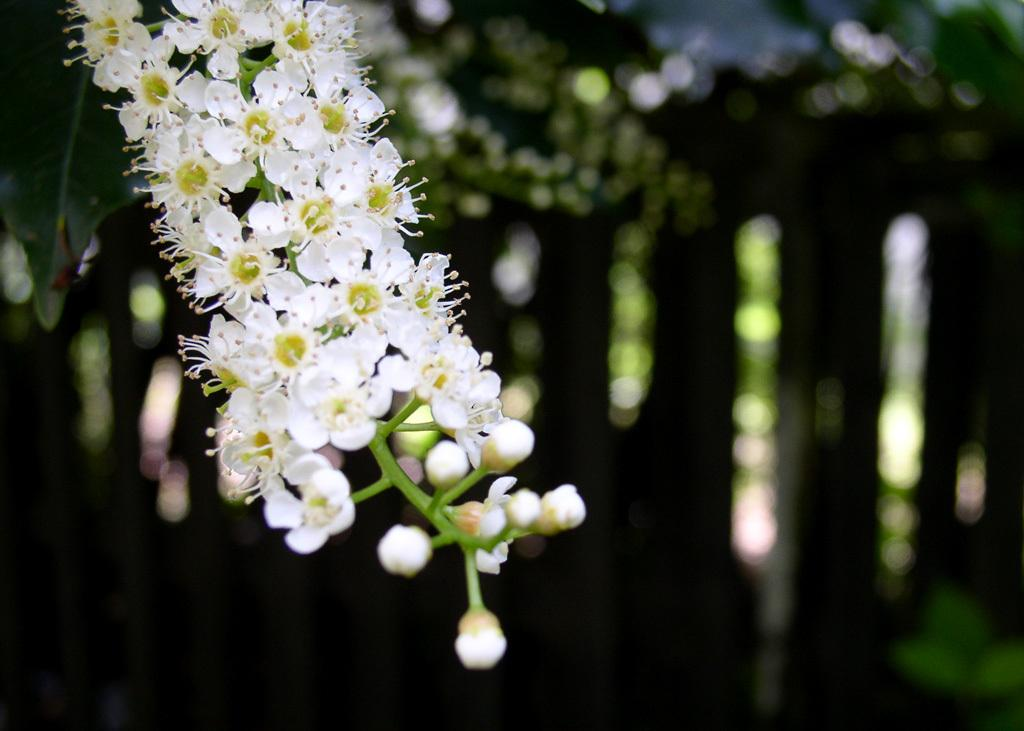What is in the foreground of the image? There are flowers on a plant in the foreground of the image. What can be seen in the background of the image? The background of the image is blurred. What type of current can be seen flowing through the flowers in the image? There is no current visible in the image; it is a still image of flowers on a plant. 